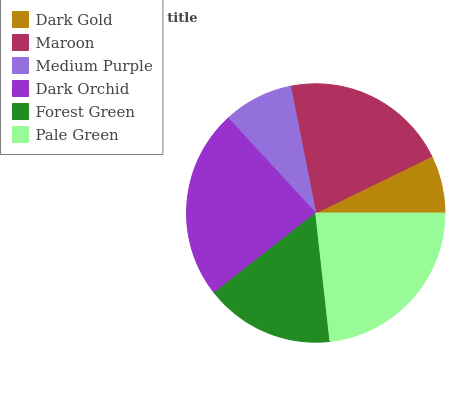Is Dark Gold the minimum?
Answer yes or no. Yes. Is Dark Orchid the maximum?
Answer yes or no. Yes. Is Maroon the minimum?
Answer yes or no. No. Is Maroon the maximum?
Answer yes or no. No. Is Maroon greater than Dark Gold?
Answer yes or no. Yes. Is Dark Gold less than Maroon?
Answer yes or no. Yes. Is Dark Gold greater than Maroon?
Answer yes or no. No. Is Maroon less than Dark Gold?
Answer yes or no. No. Is Maroon the high median?
Answer yes or no. Yes. Is Forest Green the low median?
Answer yes or no. Yes. Is Medium Purple the high median?
Answer yes or no. No. Is Maroon the low median?
Answer yes or no. No. 